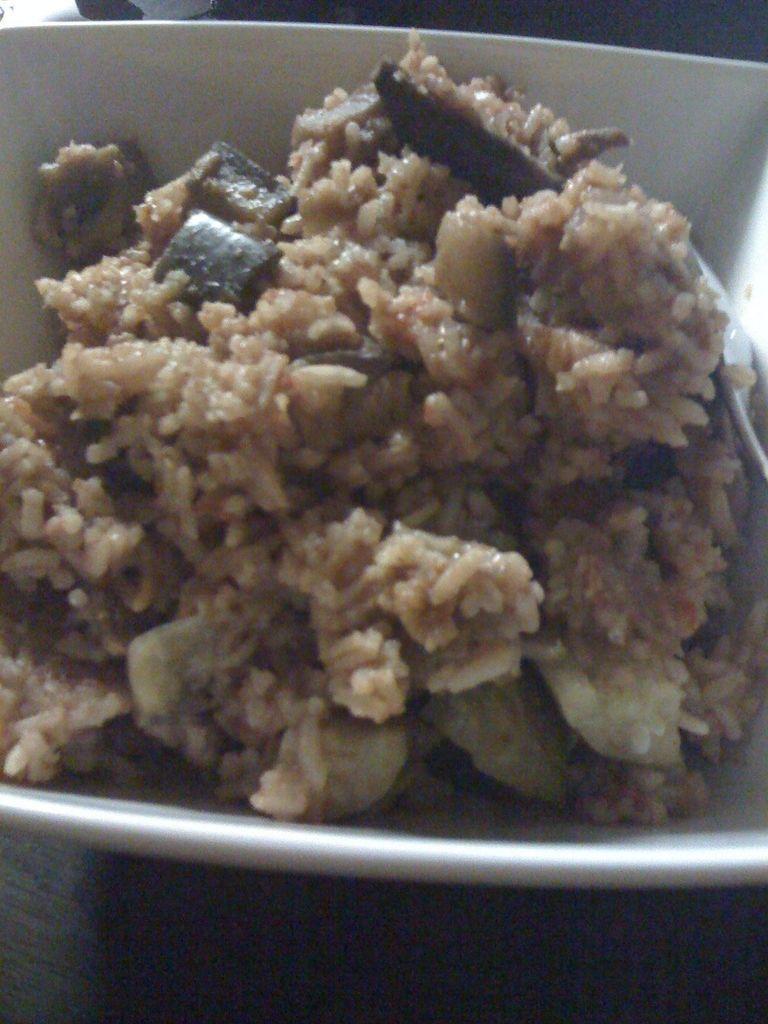Could you give a brief overview of what you see in this image? In this image I can see food which is in brown color in the bowl and the bowl is in white color. 